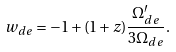Convert formula to latex. <formula><loc_0><loc_0><loc_500><loc_500>w _ { d e } = - 1 + ( 1 + z ) \frac { \Omega _ { d e } ^ { \prime } } { 3 \Omega _ { d e } } .</formula> 